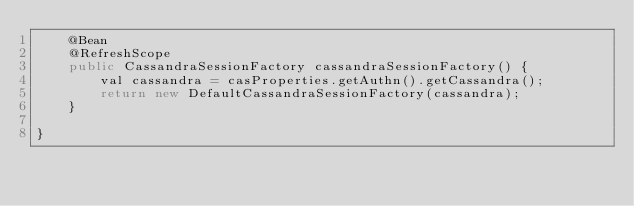<code> <loc_0><loc_0><loc_500><loc_500><_Java_>    @Bean
    @RefreshScope
    public CassandraSessionFactory cassandraSessionFactory() {
        val cassandra = casProperties.getAuthn().getCassandra();
        return new DefaultCassandraSessionFactory(cassandra);
    }

}
</code> 